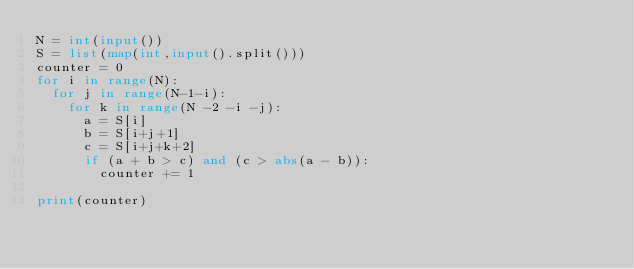<code> <loc_0><loc_0><loc_500><loc_500><_Python_>N = int(input())
S = list(map(int,input().split()))
counter = 0
for i in range(N):
  for j in range(N-1-i):
    for k in range(N -2 -i -j):
      a = S[i]
      b = S[i+j+1]
      c = S[i+j+k+2]
      if (a + b > c) and (c > abs(a - b)):
        counter += 1
    
print(counter)</code> 